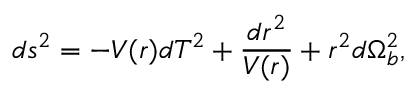<formula> <loc_0><loc_0><loc_500><loc_500>d s ^ { 2 } = - V ( r ) d T ^ { 2 } + \frac { d r ^ { 2 } } { V ( r ) } + r ^ { 2 } d \Omega _ { b } ^ { 2 } ,</formula> 